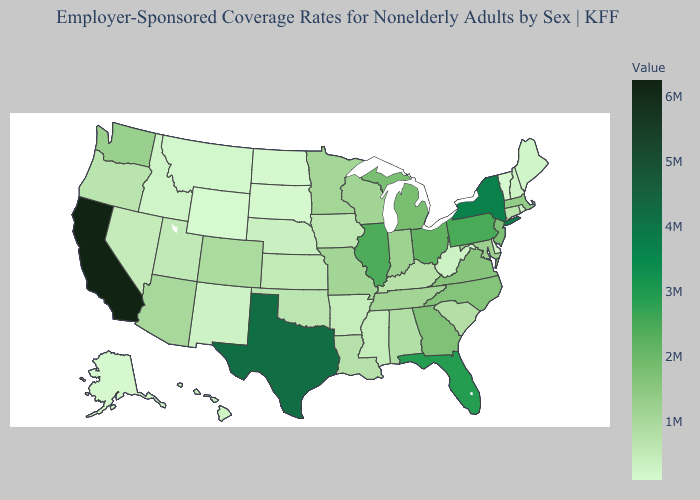Which states have the highest value in the USA?
Answer briefly. California. Does California have the highest value in the USA?
Write a very short answer. Yes. Which states hav the highest value in the South?
Quick response, please. Texas. Among the states that border Washington , which have the highest value?
Be succinct. Oregon. Among the states that border Delaware , which have the highest value?
Give a very brief answer. Pennsylvania. 